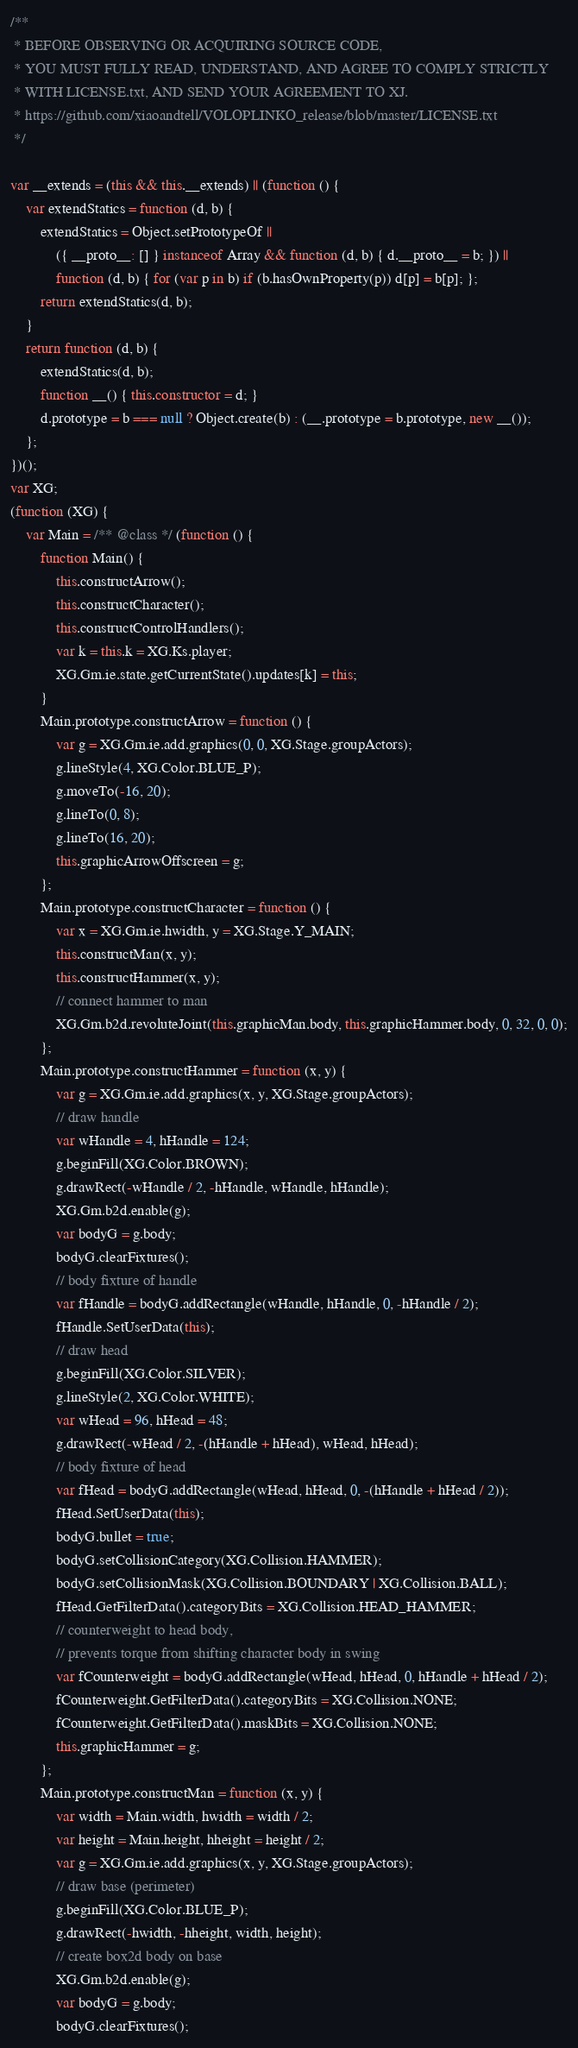Convert code to text. <code><loc_0><loc_0><loc_500><loc_500><_JavaScript_>/**
 * BEFORE OBSERVING OR ACQUIRING SOURCE CODE,
 * YOU MUST FULLY READ, UNDERSTAND, AND AGREE TO COMPLY STRICTLY
 * WITH LICENSE.txt, AND SEND YOUR AGREEMENT TO XJ.
 * https://github.com/xiaoandtell/VOLOPLINKO_release/blob/master/LICENSE.txt
 */

var __extends = (this && this.__extends) || (function () {
    var extendStatics = function (d, b) {
        extendStatics = Object.setPrototypeOf ||
            ({ __proto__: [] } instanceof Array && function (d, b) { d.__proto__ = b; }) ||
            function (d, b) { for (var p in b) if (b.hasOwnProperty(p)) d[p] = b[p]; };
        return extendStatics(d, b);
    }
    return function (d, b) {
        extendStatics(d, b);
        function __() { this.constructor = d; }
        d.prototype = b === null ? Object.create(b) : (__.prototype = b.prototype, new __());
    };
})();
var XG;
(function (XG) {
    var Main = /** @class */ (function () {
        function Main() {
            this.constructArrow();
            this.constructCharacter();
            this.constructControlHandlers();
            var k = this.k = XG.Ks.player;
            XG.Gm.ie.state.getCurrentState().updates[k] = this;
        }
        Main.prototype.constructArrow = function () {
            var g = XG.Gm.ie.add.graphics(0, 0, XG.Stage.groupActors);
            g.lineStyle(4, XG.Color.BLUE_P);
            g.moveTo(-16, 20);
            g.lineTo(0, 8);
            g.lineTo(16, 20);
            this.graphicArrowOffscreen = g;
        };
        Main.prototype.constructCharacter = function () {
            var x = XG.Gm.ie.hwidth, y = XG.Stage.Y_MAIN;
            this.constructMan(x, y);
            this.constructHammer(x, y);
            // connect hammer to man
            XG.Gm.b2d.revoluteJoint(this.graphicMan.body, this.graphicHammer.body, 0, 32, 0, 0);
        };
        Main.prototype.constructHammer = function (x, y) {
            var g = XG.Gm.ie.add.graphics(x, y, XG.Stage.groupActors);
            // draw handle
            var wHandle = 4, hHandle = 124;
            g.beginFill(XG.Color.BROWN);
            g.drawRect(-wHandle / 2, -hHandle, wHandle, hHandle);
            XG.Gm.b2d.enable(g);
            var bodyG = g.body;
            bodyG.clearFixtures();
            // body fixture of handle
            var fHandle = bodyG.addRectangle(wHandle, hHandle, 0, -hHandle / 2);
            fHandle.SetUserData(this);
            // draw head
            g.beginFill(XG.Color.SILVER);
            g.lineStyle(2, XG.Color.WHITE);
            var wHead = 96, hHead = 48;
            g.drawRect(-wHead / 2, -(hHandle + hHead), wHead, hHead);
            // body fixture of head
            var fHead = bodyG.addRectangle(wHead, hHead, 0, -(hHandle + hHead / 2));
            fHead.SetUserData(this);
            bodyG.bullet = true;
            bodyG.setCollisionCategory(XG.Collision.HAMMER);
            bodyG.setCollisionMask(XG.Collision.BOUNDARY | XG.Collision.BALL);
            fHead.GetFilterData().categoryBits = XG.Collision.HEAD_HAMMER;
            // counterweight to head body,
            // prevents torque from shifting character body in swing
            var fCounterweight = bodyG.addRectangle(wHead, hHead, 0, hHandle + hHead / 2);
            fCounterweight.GetFilterData().categoryBits = XG.Collision.NONE;
            fCounterweight.GetFilterData().maskBits = XG.Collision.NONE;
            this.graphicHammer = g;
        };
        Main.prototype.constructMan = function (x, y) {
            var width = Main.width, hwidth = width / 2;
            var height = Main.height, hheight = height / 2;
            var g = XG.Gm.ie.add.graphics(x, y, XG.Stage.groupActors);
            // draw base (perimeter)
            g.beginFill(XG.Color.BLUE_P);
            g.drawRect(-hwidth, -hheight, width, height);
            // create box2d body on base
            XG.Gm.b2d.enable(g);
            var bodyG = g.body;
            bodyG.clearFixtures();</code> 